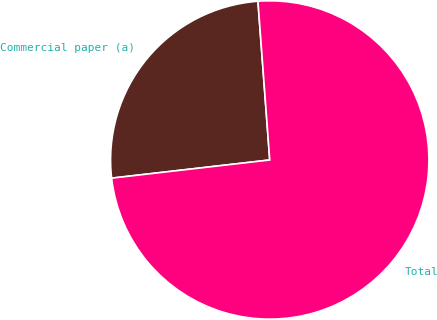<chart> <loc_0><loc_0><loc_500><loc_500><pie_chart><fcel>Commercial paper (a)<fcel>Total<nl><fcel>25.64%<fcel>74.36%<nl></chart> 